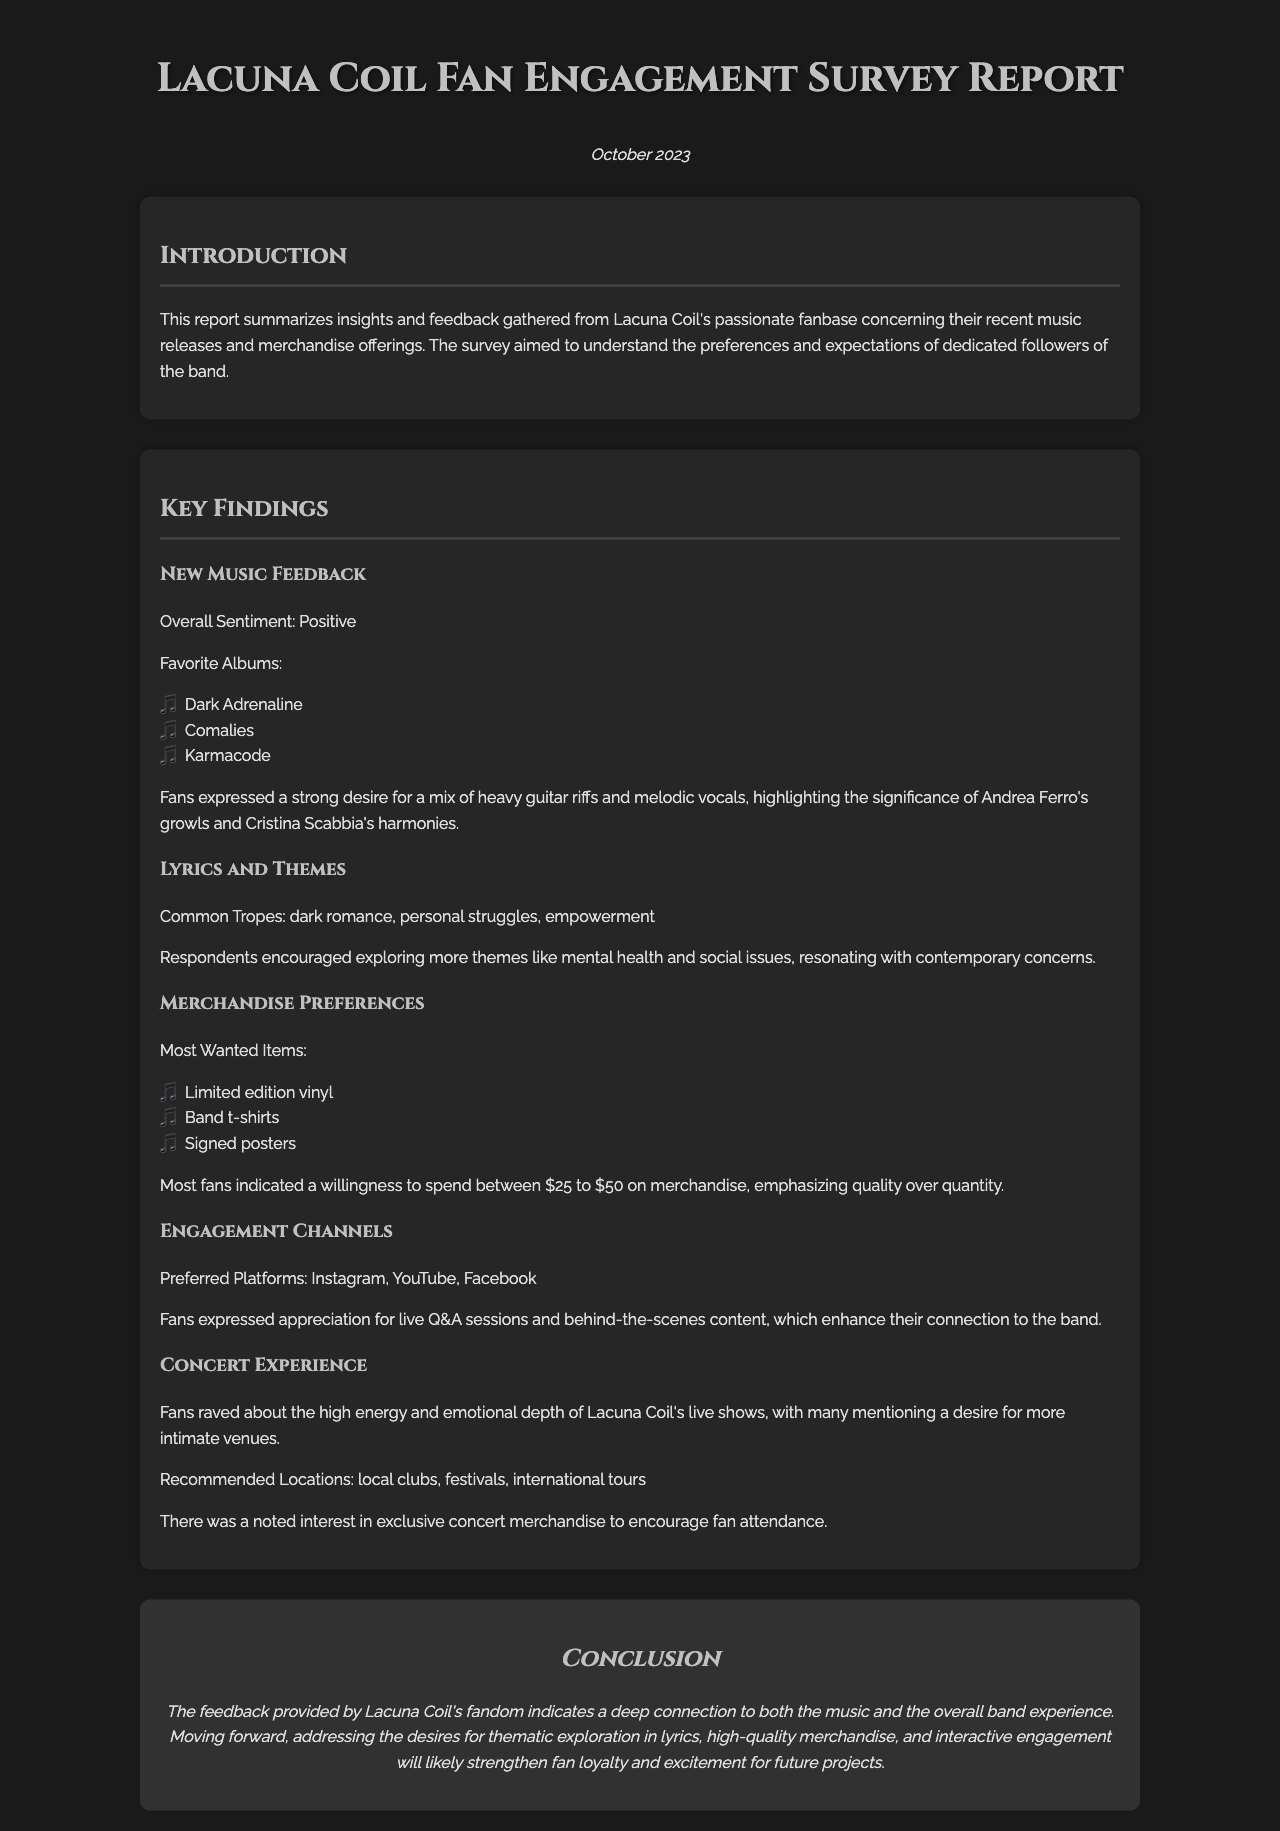what is the date of the report? The report was published in October 2023, as stated in the document.
Answer: October 2023 what are the favorite albums mentioned? The document lists favorite albums based on fan feedback, which are Dark Adrenaline, Comalies, and Karmacode.
Answer: Dark Adrenaline, Comalies, Karmacode what are the most wanted merchandise items? The report specifies what merchandise fans most desire, including limited edition vinyl, band t-shirts, and signed posters.
Answer: Limited edition vinyl, band t-shirts, signed posters what is the common theme suggested for lyrics? Fans indicated common themes they would like to see in lyrics, which includes dark romance, personal struggles, and empowerment.
Answer: dark romance, personal struggles, empowerment which engagement platforms are preferred by fans? The preferred engagement platforms mentioned in the survey include Instagram, YouTube, and Facebook.
Answer: Instagram, YouTube, Facebook what type of venues do fans desire for concerts? Fans expressed a desire for a more intimate concert experience, specifically local clubs and festivals.
Answer: local clubs, festivals how much are fans willing to spend on merchandise? The document states that most fans are willing to spend between $25 to $50 on merchandise.
Answer: $25 to $50 what emotional aspect do fans appreciate in live shows? The survey highlighted that fans appreciate the high energy and emotional depth during Lacuna Coil's live performances.
Answer: high energy and emotional depth 